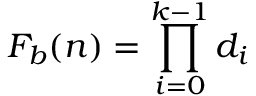<formula> <loc_0><loc_0><loc_500><loc_500>F _ { b } ( n ) = \prod _ { i = 0 } ^ { k - 1 } d _ { i }</formula> 